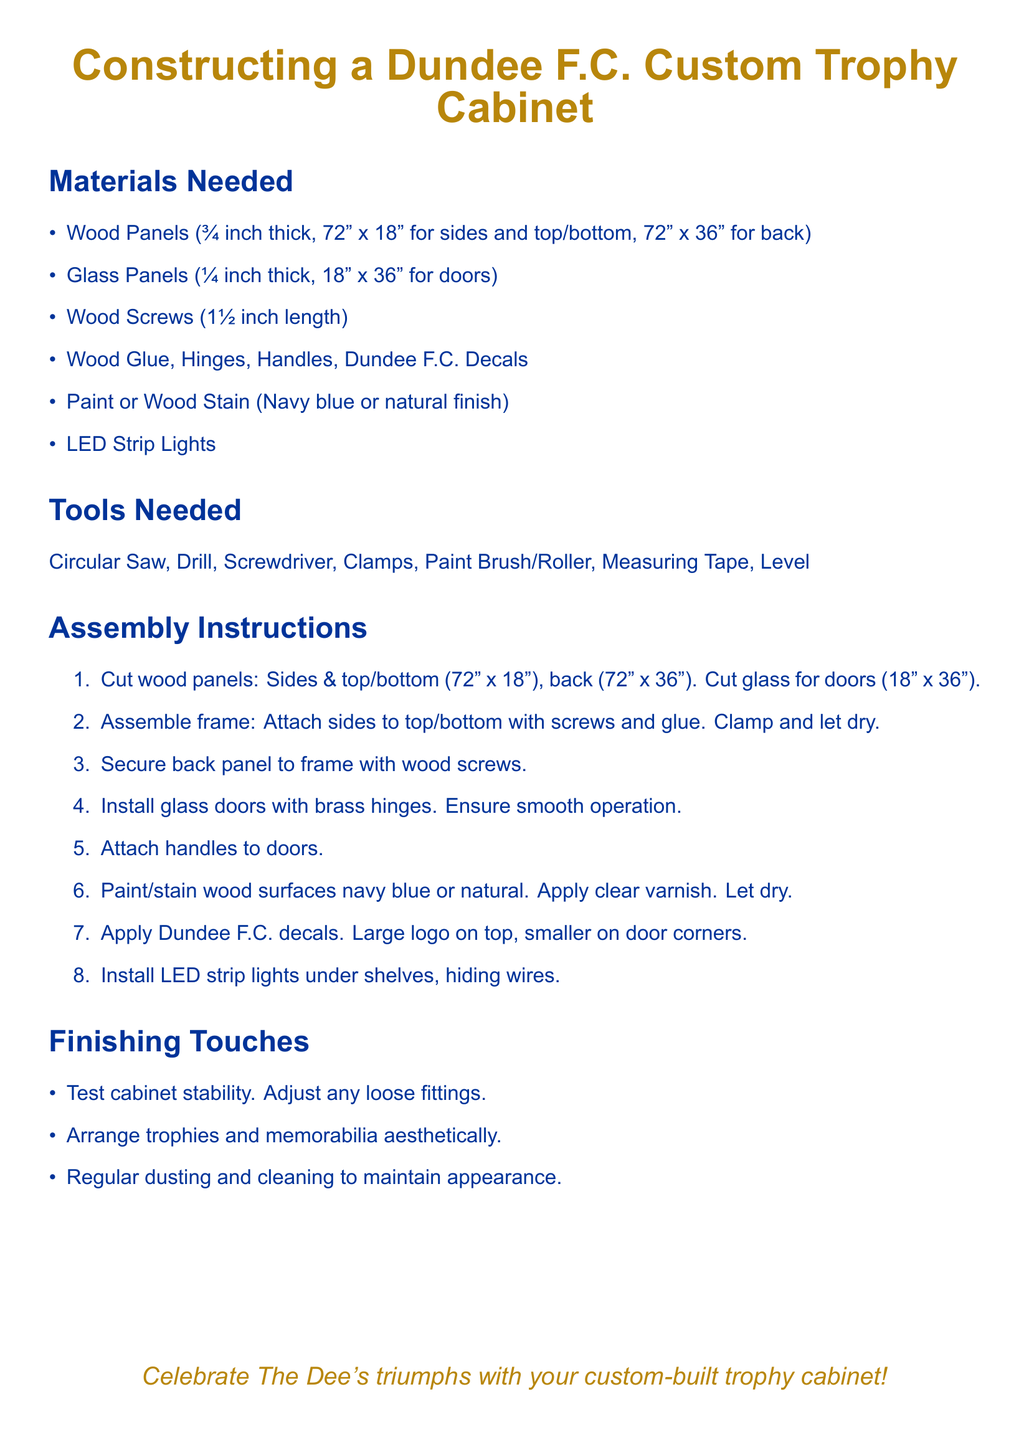What is the thickness of the wood panels? The thickness of the wood panels is specified in the materials section of the document.
Answer: ¾ inch What are the dimensions of the back panel? The dimensions of the back panel are provided in the materials list.
Answer: 72" x 36" How long are the wood screws needed? The required length for the wood screws is mentioned in the materials section.
Answer: 1½ inch Which color should the wood surfaces be painted? The paint options for the wood surfaces are listed in the materials section.
Answer: Navy blue or natural finish What should be used to install the glass doors? The instructions mention tooling needed for installing glass doors in the assembly section.
Answer: Brass hinges What is the function of the LED strip lights? The function of LED strip lights is detailed in the assembly instructions.
Answer: Under shelves What is the purpose of applying decals? The application of decals is mentioned in the assembly instructions and serves a specific purpose.
Answer: Aesthetic enhancement What should be done to maintain the cabinet's appearance? The document includes suggestions for maintenance in the finishing touches section.
Answer: Regular dusting and cleaning What is the first step in the assembly process? The assembly section outlines specific steps, and the first one is described there.
Answer: Cut wood panels 